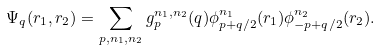<formula> <loc_0><loc_0><loc_500><loc_500>\Psi _ { q } ( { r } _ { 1 } , { r } _ { 2 } ) = \sum _ { { p } , n _ { 1 } , n _ { 2 } } g _ { p } ^ { n _ { 1 } , n _ { 2 } } ( { q } ) \phi ^ { n _ { 1 } } _ { { p } + { q } / 2 } ( { r } _ { 1 } ) \phi ^ { n _ { 2 } } _ { - { p } + { q } / 2 } ( { r } _ { 2 } ) .</formula> 